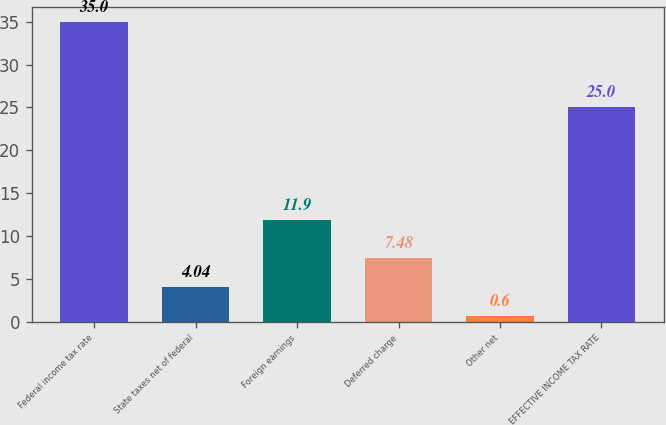Convert chart to OTSL. <chart><loc_0><loc_0><loc_500><loc_500><bar_chart><fcel>Federal income tax rate<fcel>State taxes net of federal<fcel>Foreign earnings<fcel>Deferred charge<fcel>Other net<fcel>EFFECTIVE INCOME TAX RATE<nl><fcel>35<fcel>4.04<fcel>11.9<fcel>7.48<fcel>0.6<fcel>25<nl></chart> 